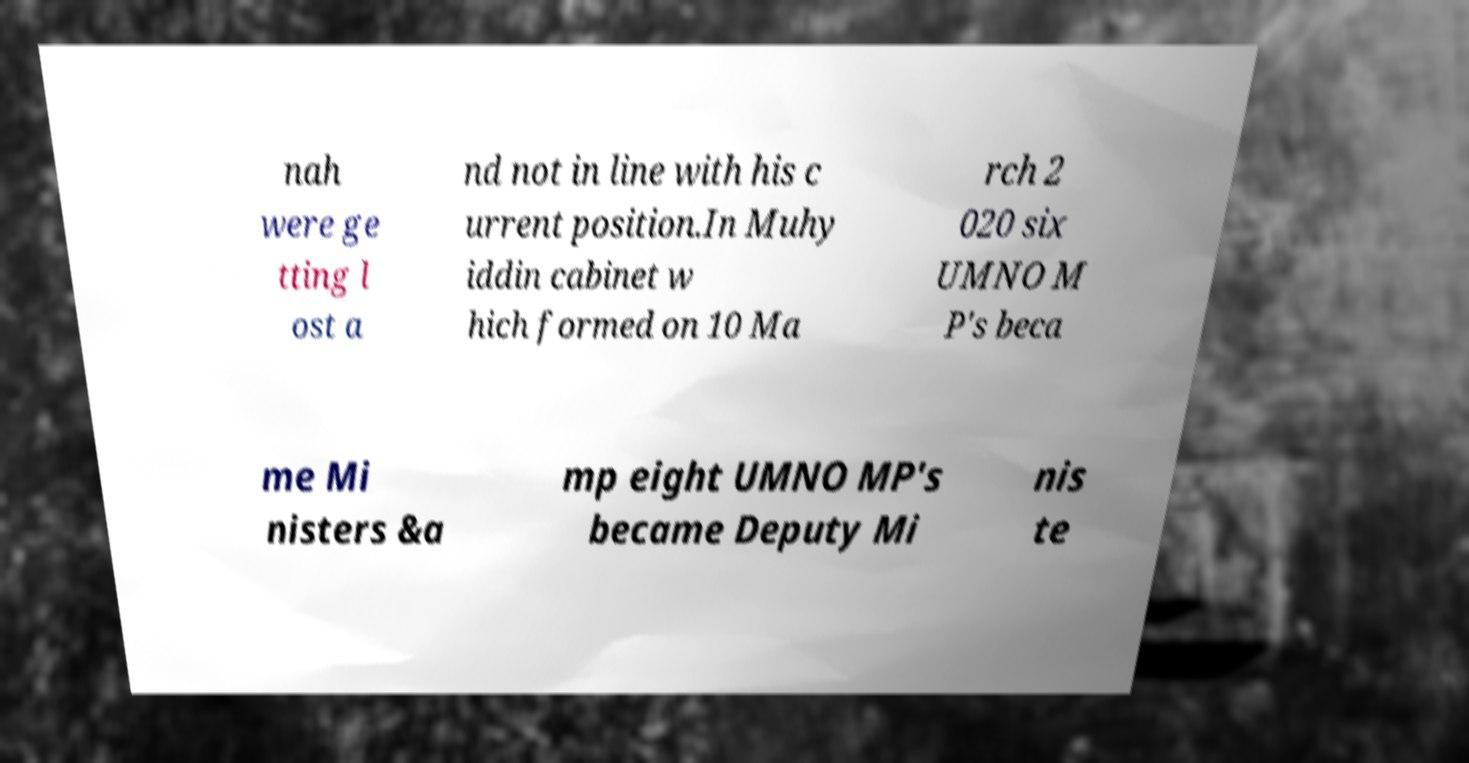Could you extract and type out the text from this image? nah were ge tting l ost a nd not in line with his c urrent position.In Muhy iddin cabinet w hich formed on 10 Ma rch 2 020 six UMNO M P's beca me Mi nisters &a mp eight UMNO MP's became Deputy Mi nis te 